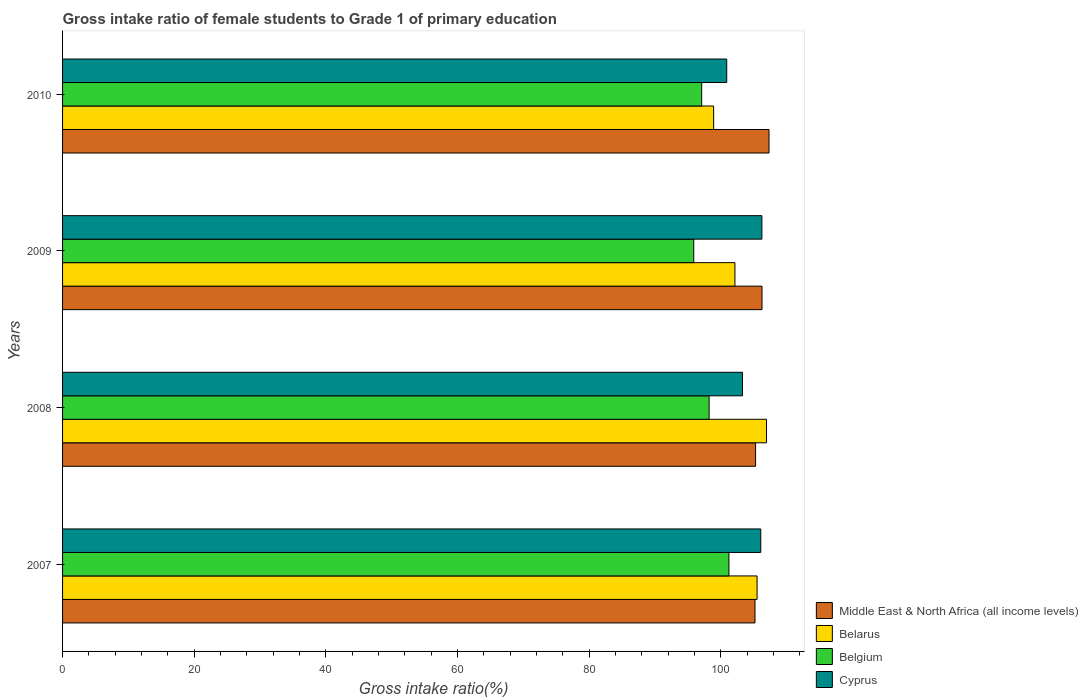Are the number of bars on each tick of the Y-axis equal?
Your response must be concise. Yes. How many bars are there on the 2nd tick from the bottom?
Ensure brevity in your answer.  4. What is the label of the 3rd group of bars from the top?
Offer a terse response. 2008. In how many cases, is the number of bars for a given year not equal to the number of legend labels?
Give a very brief answer. 0. What is the gross intake ratio in Middle East & North Africa (all income levels) in 2010?
Provide a short and direct response. 107.31. Across all years, what is the maximum gross intake ratio in Belarus?
Your answer should be very brief. 106.93. Across all years, what is the minimum gross intake ratio in Belarus?
Make the answer very short. 98.9. In which year was the gross intake ratio in Belgium maximum?
Keep it short and to the point. 2007. What is the total gross intake ratio in Cyprus in the graph?
Provide a short and direct response. 416.44. What is the difference between the gross intake ratio in Belgium in 2008 and that in 2010?
Make the answer very short. 1.13. What is the difference between the gross intake ratio in Cyprus in 2010 and the gross intake ratio in Belgium in 2009?
Make the answer very short. 5.01. What is the average gross intake ratio in Belarus per year?
Make the answer very short. 103.36. In the year 2008, what is the difference between the gross intake ratio in Cyprus and gross intake ratio in Middle East & North Africa (all income levels)?
Ensure brevity in your answer.  -1.99. In how many years, is the gross intake ratio in Cyprus greater than 24 %?
Keep it short and to the point. 4. What is the ratio of the gross intake ratio in Belarus in 2009 to that in 2010?
Provide a short and direct response. 1.03. Is the gross intake ratio in Middle East & North Africa (all income levels) in 2007 less than that in 2008?
Your answer should be compact. Yes. Is the difference between the gross intake ratio in Cyprus in 2009 and 2010 greater than the difference between the gross intake ratio in Middle East & North Africa (all income levels) in 2009 and 2010?
Make the answer very short. Yes. What is the difference between the highest and the second highest gross intake ratio in Belgium?
Make the answer very short. 3.01. What is the difference between the highest and the lowest gross intake ratio in Middle East & North Africa (all income levels)?
Your response must be concise. 2.13. In how many years, is the gross intake ratio in Middle East & North Africa (all income levels) greater than the average gross intake ratio in Middle East & North Africa (all income levels) taken over all years?
Give a very brief answer. 2. Is the sum of the gross intake ratio in Belarus in 2007 and 2010 greater than the maximum gross intake ratio in Cyprus across all years?
Make the answer very short. Yes. What does the 4th bar from the bottom in 2009 represents?
Your answer should be compact. Cyprus. Are the values on the major ticks of X-axis written in scientific E-notation?
Offer a very short reply. No. Where does the legend appear in the graph?
Make the answer very short. Bottom right. What is the title of the graph?
Your response must be concise. Gross intake ratio of female students to Grade 1 of primary education. Does "Chad" appear as one of the legend labels in the graph?
Keep it short and to the point. No. What is the label or title of the X-axis?
Ensure brevity in your answer.  Gross intake ratio(%). What is the label or title of the Y-axis?
Provide a succinct answer. Years. What is the Gross intake ratio(%) of Middle East & North Africa (all income levels) in 2007?
Provide a short and direct response. 105.18. What is the Gross intake ratio(%) of Belarus in 2007?
Your answer should be very brief. 105.5. What is the Gross intake ratio(%) in Belgium in 2007?
Your response must be concise. 101.22. What is the Gross intake ratio(%) of Cyprus in 2007?
Keep it short and to the point. 106.05. What is the Gross intake ratio(%) of Middle East & North Africa (all income levels) in 2008?
Keep it short and to the point. 105.27. What is the Gross intake ratio(%) in Belarus in 2008?
Ensure brevity in your answer.  106.93. What is the Gross intake ratio(%) in Belgium in 2008?
Ensure brevity in your answer.  98.21. What is the Gross intake ratio(%) in Cyprus in 2008?
Your answer should be compact. 103.27. What is the Gross intake ratio(%) in Middle East & North Africa (all income levels) in 2009?
Your answer should be very brief. 106.24. What is the Gross intake ratio(%) of Belarus in 2009?
Keep it short and to the point. 102.13. What is the Gross intake ratio(%) in Belgium in 2009?
Provide a short and direct response. 95.87. What is the Gross intake ratio(%) of Cyprus in 2009?
Your answer should be very brief. 106.23. What is the Gross intake ratio(%) in Middle East & North Africa (all income levels) in 2010?
Provide a short and direct response. 107.31. What is the Gross intake ratio(%) of Belarus in 2010?
Your answer should be very brief. 98.9. What is the Gross intake ratio(%) in Belgium in 2010?
Your response must be concise. 97.08. What is the Gross intake ratio(%) of Cyprus in 2010?
Provide a short and direct response. 100.89. Across all years, what is the maximum Gross intake ratio(%) of Middle East & North Africa (all income levels)?
Offer a terse response. 107.31. Across all years, what is the maximum Gross intake ratio(%) in Belarus?
Offer a very short reply. 106.93. Across all years, what is the maximum Gross intake ratio(%) of Belgium?
Your answer should be compact. 101.22. Across all years, what is the maximum Gross intake ratio(%) in Cyprus?
Offer a very short reply. 106.23. Across all years, what is the minimum Gross intake ratio(%) of Middle East & North Africa (all income levels)?
Ensure brevity in your answer.  105.18. Across all years, what is the minimum Gross intake ratio(%) of Belarus?
Your response must be concise. 98.9. Across all years, what is the minimum Gross intake ratio(%) in Belgium?
Make the answer very short. 95.87. Across all years, what is the minimum Gross intake ratio(%) in Cyprus?
Keep it short and to the point. 100.89. What is the total Gross intake ratio(%) of Middle East & North Africa (all income levels) in the graph?
Offer a very short reply. 424. What is the total Gross intake ratio(%) in Belarus in the graph?
Your answer should be compact. 413.45. What is the total Gross intake ratio(%) in Belgium in the graph?
Provide a succinct answer. 392.38. What is the total Gross intake ratio(%) of Cyprus in the graph?
Ensure brevity in your answer.  416.44. What is the difference between the Gross intake ratio(%) in Middle East & North Africa (all income levels) in 2007 and that in 2008?
Your answer should be compact. -0.09. What is the difference between the Gross intake ratio(%) of Belarus in 2007 and that in 2008?
Keep it short and to the point. -1.43. What is the difference between the Gross intake ratio(%) in Belgium in 2007 and that in 2008?
Offer a terse response. 3.01. What is the difference between the Gross intake ratio(%) of Cyprus in 2007 and that in 2008?
Make the answer very short. 2.78. What is the difference between the Gross intake ratio(%) in Middle East & North Africa (all income levels) in 2007 and that in 2009?
Provide a short and direct response. -1.07. What is the difference between the Gross intake ratio(%) of Belarus in 2007 and that in 2009?
Ensure brevity in your answer.  3.36. What is the difference between the Gross intake ratio(%) in Belgium in 2007 and that in 2009?
Your answer should be compact. 5.34. What is the difference between the Gross intake ratio(%) of Cyprus in 2007 and that in 2009?
Provide a short and direct response. -0.17. What is the difference between the Gross intake ratio(%) of Middle East & North Africa (all income levels) in 2007 and that in 2010?
Give a very brief answer. -2.13. What is the difference between the Gross intake ratio(%) of Belarus in 2007 and that in 2010?
Ensure brevity in your answer.  6.6. What is the difference between the Gross intake ratio(%) in Belgium in 2007 and that in 2010?
Offer a terse response. 4.14. What is the difference between the Gross intake ratio(%) in Cyprus in 2007 and that in 2010?
Your answer should be very brief. 5.17. What is the difference between the Gross intake ratio(%) in Middle East & North Africa (all income levels) in 2008 and that in 2009?
Offer a very short reply. -0.98. What is the difference between the Gross intake ratio(%) in Belarus in 2008 and that in 2009?
Make the answer very short. 4.79. What is the difference between the Gross intake ratio(%) in Belgium in 2008 and that in 2009?
Your answer should be compact. 2.34. What is the difference between the Gross intake ratio(%) in Cyprus in 2008 and that in 2009?
Offer a terse response. -2.95. What is the difference between the Gross intake ratio(%) in Middle East & North Africa (all income levels) in 2008 and that in 2010?
Offer a very short reply. -2.04. What is the difference between the Gross intake ratio(%) of Belarus in 2008 and that in 2010?
Give a very brief answer. 8.03. What is the difference between the Gross intake ratio(%) of Belgium in 2008 and that in 2010?
Your answer should be compact. 1.13. What is the difference between the Gross intake ratio(%) in Cyprus in 2008 and that in 2010?
Your response must be concise. 2.39. What is the difference between the Gross intake ratio(%) of Middle East & North Africa (all income levels) in 2009 and that in 2010?
Ensure brevity in your answer.  -1.06. What is the difference between the Gross intake ratio(%) in Belarus in 2009 and that in 2010?
Keep it short and to the point. 3.24. What is the difference between the Gross intake ratio(%) of Belgium in 2009 and that in 2010?
Offer a very short reply. -1.21. What is the difference between the Gross intake ratio(%) of Cyprus in 2009 and that in 2010?
Provide a short and direct response. 5.34. What is the difference between the Gross intake ratio(%) in Middle East & North Africa (all income levels) in 2007 and the Gross intake ratio(%) in Belarus in 2008?
Provide a short and direct response. -1.75. What is the difference between the Gross intake ratio(%) in Middle East & North Africa (all income levels) in 2007 and the Gross intake ratio(%) in Belgium in 2008?
Provide a short and direct response. 6.97. What is the difference between the Gross intake ratio(%) in Middle East & North Africa (all income levels) in 2007 and the Gross intake ratio(%) in Cyprus in 2008?
Your response must be concise. 1.9. What is the difference between the Gross intake ratio(%) in Belarus in 2007 and the Gross intake ratio(%) in Belgium in 2008?
Keep it short and to the point. 7.29. What is the difference between the Gross intake ratio(%) of Belarus in 2007 and the Gross intake ratio(%) of Cyprus in 2008?
Give a very brief answer. 2.22. What is the difference between the Gross intake ratio(%) in Belgium in 2007 and the Gross intake ratio(%) in Cyprus in 2008?
Offer a terse response. -2.06. What is the difference between the Gross intake ratio(%) in Middle East & North Africa (all income levels) in 2007 and the Gross intake ratio(%) in Belarus in 2009?
Your answer should be very brief. 3.05. What is the difference between the Gross intake ratio(%) in Middle East & North Africa (all income levels) in 2007 and the Gross intake ratio(%) in Belgium in 2009?
Provide a succinct answer. 9.31. What is the difference between the Gross intake ratio(%) of Middle East & North Africa (all income levels) in 2007 and the Gross intake ratio(%) of Cyprus in 2009?
Ensure brevity in your answer.  -1.05. What is the difference between the Gross intake ratio(%) in Belarus in 2007 and the Gross intake ratio(%) in Belgium in 2009?
Offer a terse response. 9.62. What is the difference between the Gross intake ratio(%) of Belarus in 2007 and the Gross intake ratio(%) of Cyprus in 2009?
Keep it short and to the point. -0.73. What is the difference between the Gross intake ratio(%) in Belgium in 2007 and the Gross intake ratio(%) in Cyprus in 2009?
Offer a very short reply. -5.01. What is the difference between the Gross intake ratio(%) in Middle East & North Africa (all income levels) in 2007 and the Gross intake ratio(%) in Belarus in 2010?
Provide a succinct answer. 6.28. What is the difference between the Gross intake ratio(%) in Middle East & North Africa (all income levels) in 2007 and the Gross intake ratio(%) in Belgium in 2010?
Keep it short and to the point. 8.1. What is the difference between the Gross intake ratio(%) of Middle East & North Africa (all income levels) in 2007 and the Gross intake ratio(%) of Cyprus in 2010?
Provide a short and direct response. 4.29. What is the difference between the Gross intake ratio(%) in Belarus in 2007 and the Gross intake ratio(%) in Belgium in 2010?
Make the answer very short. 8.41. What is the difference between the Gross intake ratio(%) of Belarus in 2007 and the Gross intake ratio(%) of Cyprus in 2010?
Offer a terse response. 4.61. What is the difference between the Gross intake ratio(%) of Belgium in 2007 and the Gross intake ratio(%) of Cyprus in 2010?
Your answer should be compact. 0.33. What is the difference between the Gross intake ratio(%) in Middle East & North Africa (all income levels) in 2008 and the Gross intake ratio(%) in Belarus in 2009?
Your answer should be compact. 3.13. What is the difference between the Gross intake ratio(%) of Middle East & North Africa (all income levels) in 2008 and the Gross intake ratio(%) of Belgium in 2009?
Keep it short and to the point. 9.39. What is the difference between the Gross intake ratio(%) in Middle East & North Africa (all income levels) in 2008 and the Gross intake ratio(%) in Cyprus in 2009?
Provide a short and direct response. -0.96. What is the difference between the Gross intake ratio(%) of Belarus in 2008 and the Gross intake ratio(%) of Belgium in 2009?
Your answer should be very brief. 11.05. What is the difference between the Gross intake ratio(%) of Belarus in 2008 and the Gross intake ratio(%) of Cyprus in 2009?
Provide a short and direct response. 0.7. What is the difference between the Gross intake ratio(%) of Belgium in 2008 and the Gross intake ratio(%) of Cyprus in 2009?
Your answer should be compact. -8.02. What is the difference between the Gross intake ratio(%) of Middle East & North Africa (all income levels) in 2008 and the Gross intake ratio(%) of Belarus in 2010?
Provide a short and direct response. 6.37. What is the difference between the Gross intake ratio(%) in Middle East & North Africa (all income levels) in 2008 and the Gross intake ratio(%) in Belgium in 2010?
Keep it short and to the point. 8.19. What is the difference between the Gross intake ratio(%) in Middle East & North Africa (all income levels) in 2008 and the Gross intake ratio(%) in Cyprus in 2010?
Provide a succinct answer. 4.38. What is the difference between the Gross intake ratio(%) in Belarus in 2008 and the Gross intake ratio(%) in Belgium in 2010?
Offer a terse response. 9.85. What is the difference between the Gross intake ratio(%) in Belarus in 2008 and the Gross intake ratio(%) in Cyprus in 2010?
Keep it short and to the point. 6.04. What is the difference between the Gross intake ratio(%) of Belgium in 2008 and the Gross intake ratio(%) of Cyprus in 2010?
Provide a succinct answer. -2.68. What is the difference between the Gross intake ratio(%) of Middle East & North Africa (all income levels) in 2009 and the Gross intake ratio(%) of Belarus in 2010?
Provide a succinct answer. 7.35. What is the difference between the Gross intake ratio(%) in Middle East & North Africa (all income levels) in 2009 and the Gross intake ratio(%) in Belgium in 2010?
Provide a short and direct response. 9.16. What is the difference between the Gross intake ratio(%) in Middle East & North Africa (all income levels) in 2009 and the Gross intake ratio(%) in Cyprus in 2010?
Your response must be concise. 5.36. What is the difference between the Gross intake ratio(%) of Belarus in 2009 and the Gross intake ratio(%) of Belgium in 2010?
Give a very brief answer. 5.05. What is the difference between the Gross intake ratio(%) of Belarus in 2009 and the Gross intake ratio(%) of Cyprus in 2010?
Make the answer very short. 1.25. What is the difference between the Gross intake ratio(%) in Belgium in 2009 and the Gross intake ratio(%) in Cyprus in 2010?
Ensure brevity in your answer.  -5.01. What is the average Gross intake ratio(%) in Middle East & North Africa (all income levels) per year?
Give a very brief answer. 106. What is the average Gross intake ratio(%) of Belarus per year?
Offer a terse response. 103.36. What is the average Gross intake ratio(%) in Belgium per year?
Make the answer very short. 98.09. What is the average Gross intake ratio(%) in Cyprus per year?
Offer a very short reply. 104.11. In the year 2007, what is the difference between the Gross intake ratio(%) of Middle East & North Africa (all income levels) and Gross intake ratio(%) of Belarus?
Your answer should be very brief. -0.32. In the year 2007, what is the difference between the Gross intake ratio(%) of Middle East & North Africa (all income levels) and Gross intake ratio(%) of Belgium?
Provide a succinct answer. 3.96. In the year 2007, what is the difference between the Gross intake ratio(%) of Middle East & North Africa (all income levels) and Gross intake ratio(%) of Cyprus?
Ensure brevity in your answer.  -0.88. In the year 2007, what is the difference between the Gross intake ratio(%) in Belarus and Gross intake ratio(%) in Belgium?
Offer a terse response. 4.28. In the year 2007, what is the difference between the Gross intake ratio(%) of Belarus and Gross intake ratio(%) of Cyprus?
Your response must be concise. -0.56. In the year 2007, what is the difference between the Gross intake ratio(%) of Belgium and Gross intake ratio(%) of Cyprus?
Keep it short and to the point. -4.84. In the year 2008, what is the difference between the Gross intake ratio(%) of Middle East & North Africa (all income levels) and Gross intake ratio(%) of Belarus?
Keep it short and to the point. -1.66. In the year 2008, what is the difference between the Gross intake ratio(%) of Middle East & North Africa (all income levels) and Gross intake ratio(%) of Belgium?
Your response must be concise. 7.06. In the year 2008, what is the difference between the Gross intake ratio(%) of Middle East & North Africa (all income levels) and Gross intake ratio(%) of Cyprus?
Provide a succinct answer. 1.99. In the year 2008, what is the difference between the Gross intake ratio(%) of Belarus and Gross intake ratio(%) of Belgium?
Your response must be concise. 8.72. In the year 2008, what is the difference between the Gross intake ratio(%) of Belarus and Gross intake ratio(%) of Cyprus?
Make the answer very short. 3.65. In the year 2008, what is the difference between the Gross intake ratio(%) in Belgium and Gross intake ratio(%) in Cyprus?
Offer a very short reply. -5.07. In the year 2009, what is the difference between the Gross intake ratio(%) in Middle East & North Africa (all income levels) and Gross intake ratio(%) in Belarus?
Make the answer very short. 4.11. In the year 2009, what is the difference between the Gross intake ratio(%) of Middle East & North Africa (all income levels) and Gross intake ratio(%) of Belgium?
Give a very brief answer. 10.37. In the year 2009, what is the difference between the Gross intake ratio(%) in Middle East & North Africa (all income levels) and Gross intake ratio(%) in Cyprus?
Give a very brief answer. 0.02. In the year 2009, what is the difference between the Gross intake ratio(%) of Belarus and Gross intake ratio(%) of Belgium?
Make the answer very short. 6.26. In the year 2009, what is the difference between the Gross intake ratio(%) of Belarus and Gross intake ratio(%) of Cyprus?
Keep it short and to the point. -4.09. In the year 2009, what is the difference between the Gross intake ratio(%) in Belgium and Gross intake ratio(%) in Cyprus?
Offer a terse response. -10.35. In the year 2010, what is the difference between the Gross intake ratio(%) in Middle East & North Africa (all income levels) and Gross intake ratio(%) in Belarus?
Offer a terse response. 8.41. In the year 2010, what is the difference between the Gross intake ratio(%) of Middle East & North Africa (all income levels) and Gross intake ratio(%) of Belgium?
Offer a very short reply. 10.23. In the year 2010, what is the difference between the Gross intake ratio(%) of Middle East & North Africa (all income levels) and Gross intake ratio(%) of Cyprus?
Offer a terse response. 6.42. In the year 2010, what is the difference between the Gross intake ratio(%) in Belarus and Gross intake ratio(%) in Belgium?
Your answer should be compact. 1.81. In the year 2010, what is the difference between the Gross intake ratio(%) in Belarus and Gross intake ratio(%) in Cyprus?
Keep it short and to the point. -1.99. In the year 2010, what is the difference between the Gross intake ratio(%) of Belgium and Gross intake ratio(%) of Cyprus?
Offer a very short reply. -3.8. What is the ratio of the Gross intake ratio(%) of Belarus in 2007 to that in 2008?
Your answer should be compact. 0.99. What is the ratio of the Gross intake ratio(%) in Belgium in 2007 to that in 2008?
Keep it short and to the point. 1.03. What is the ratio of the Gross intake ratio(%) of Cyprus in 2007 to that in 2008?
Give a very brief answer. 1.03. What is the ratio of the Gross intake ratio(%) in Middle East & North Africa (all income levels) in 2007 to that in 2009?
Ensure brevity in your answer.  0.99. What is the ratio of the Gross intake ratio(%) of Belarus in 2007 to that in 2009?
Give a very brief answer. 1.03. What is the ratio of the Gross intake ratio(%) in Belgium in 2007 to that in 2009?
Provide a succinct answer. 1.06. What is the ratio of the Gross intake ratio(%) in Cyprus in 2007 to that in 2009?
Provide a short and direct response. 1. What is the ratio of the Gross intake ratio(%) of Middle East & North Africa (all income levels) in 2007 to that in 2010?
Keep it short and to the point. 0.98. What is the ratio of the Gross intake ratio(%) in Belarus in 2007 to that in 2010?
Provide a succinct answer. 1.07. What is the ratio of the Gross intake ratio(%) of Belgium in 2007 to that in 2010?
Offer a terse response. 1.04. What is the ratio of the Gross intake ratio(%) of Cyprus in 2007 to that in 2010?
Offer a terse response. 1.05. What is the ratio of the Gross intake ratio(%) of Belarus in 2008 to that in 2009?
Give a very brief answer. 1.05. What is the ratio of the Gross intake ratio(%) of Belgium in 2008 to that in 2009?
Give a very brief answer. 1.02. What is the ratio of the Gross intake ratio(%) of Cyprus in 2008 to that in 2009?
Offer a very short reply. 0.97. What is the ratio of the Gross intake ratio(%) in Belarus in 2008 to that in 2010?
Give a very brief answer. 1.08. What is the ratio of the Gross intake ratio(%) in Belgium in 2008 to that in 2010?
Make the answer very short. 1.01. What is the ratio of the Gross intake ratio(%) in Cyprus in 2008 to that in 2010?
Provide a short and direct response. 1.02. What is the ratio of the Gross intake ratio(%) of Middle East & North Africa (all income levels) in 2009 to that in 2010?
Provide a short and direct response. 0.99. What is the ratio of the Gross intake ratio(%) in Belarus in 2009 to that in 2010?
Ensure brevity in your answer.  1.03. What is the ratio of the Gross intake ratio(%) of Belgium in 2009 to that in 2010?
Offer a very short reply. 0.99. What is the ratio of the Gross intake ratio(%) in Cyprus in 2009 to that in 2010?
Provide a succinct answer. 1.05. What is the difference between the highest and the second highest Gross intake ratio(%) of Middle East & North Africa (all income levels)?
Provide a short and direct response. 1.06. What is the difference between the highest and the second highest Gross intake ratio(%) in Belarus?
Give a very brief answer. 1.43. What is the difference between the highest and the second highest Gross intake ratio(%) in Belgium?
Offer a very short reply. 3.01. What is the difference between the highest and the second highest Gross intake ratio(%) of Cyprus?
Give a very brief answer. 0.17. What is the difference between the highest and the lowest Gross intake ratio(%) in Middle East & North Africa (all income levels)?
Make the answer very short. 2.13. What is the difference between the highest and the lowest Gross intake ratio(%) in Belarus?
Your response must be concise. 8.03. What is the difference between the highest and the lowest Gross intake ratio(%) of Belgium?
Keep it short and to the point. 5.34. What is the difference between the highest and the lowest Gross intake ratio(%) of Cyprus?
Your answer should be very brief. 5.34. 